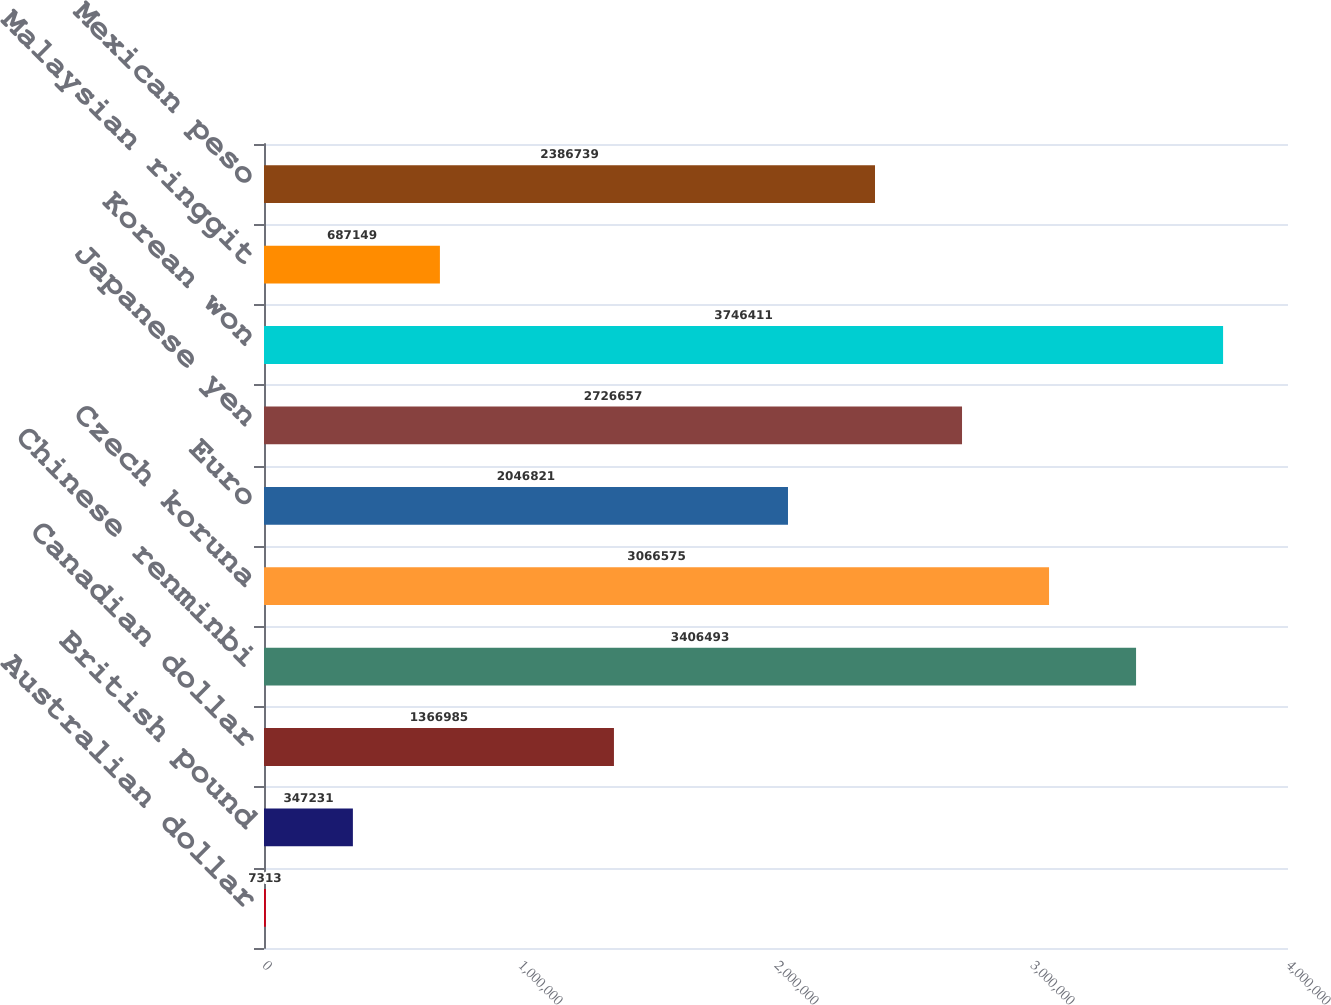<chart> <loc_0><loc_0><loc_500><loc_500><bar_chart><fcel>Australian dollar<fcel>British pound<fcel>Canadian dollar<fcel>Chinese renminbi<fcel>Czech koruna<fcel>Euro<fcel>Japanese yen<fcel>Korean won<fcel>Malaysian ringgit<fcel>Mexican peso<nl><fcel>7313<fcel>347231<fcel>1.36698e+06<fcel>3.40649e+06<fcel>3.06658e+06<fcel>2.04682e+06<fcel>2.72666e+06<fcel>3.74641e+06<fcel>687149<fcel>2.38674e+06<nl></chart> 